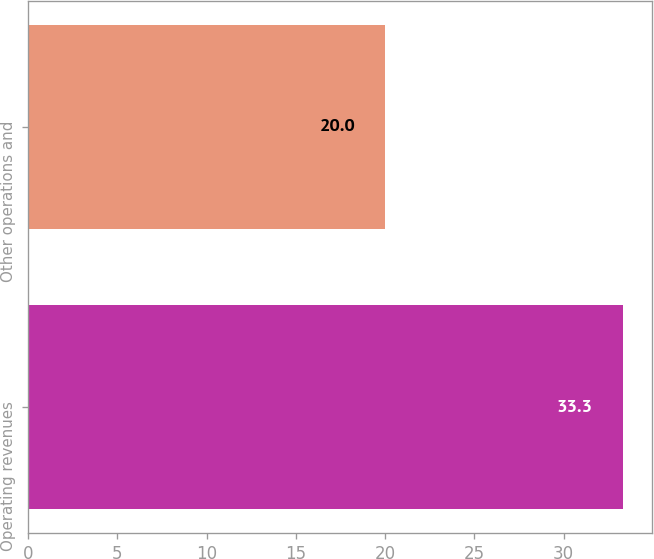Convert chart. <chart><loc_0><loc_0><loc_500><loc_500><bar_chart><fcel>Operating revenues<fcel>Other operations and<nl><fcel>33.3<fcel>20<nl></chart> 